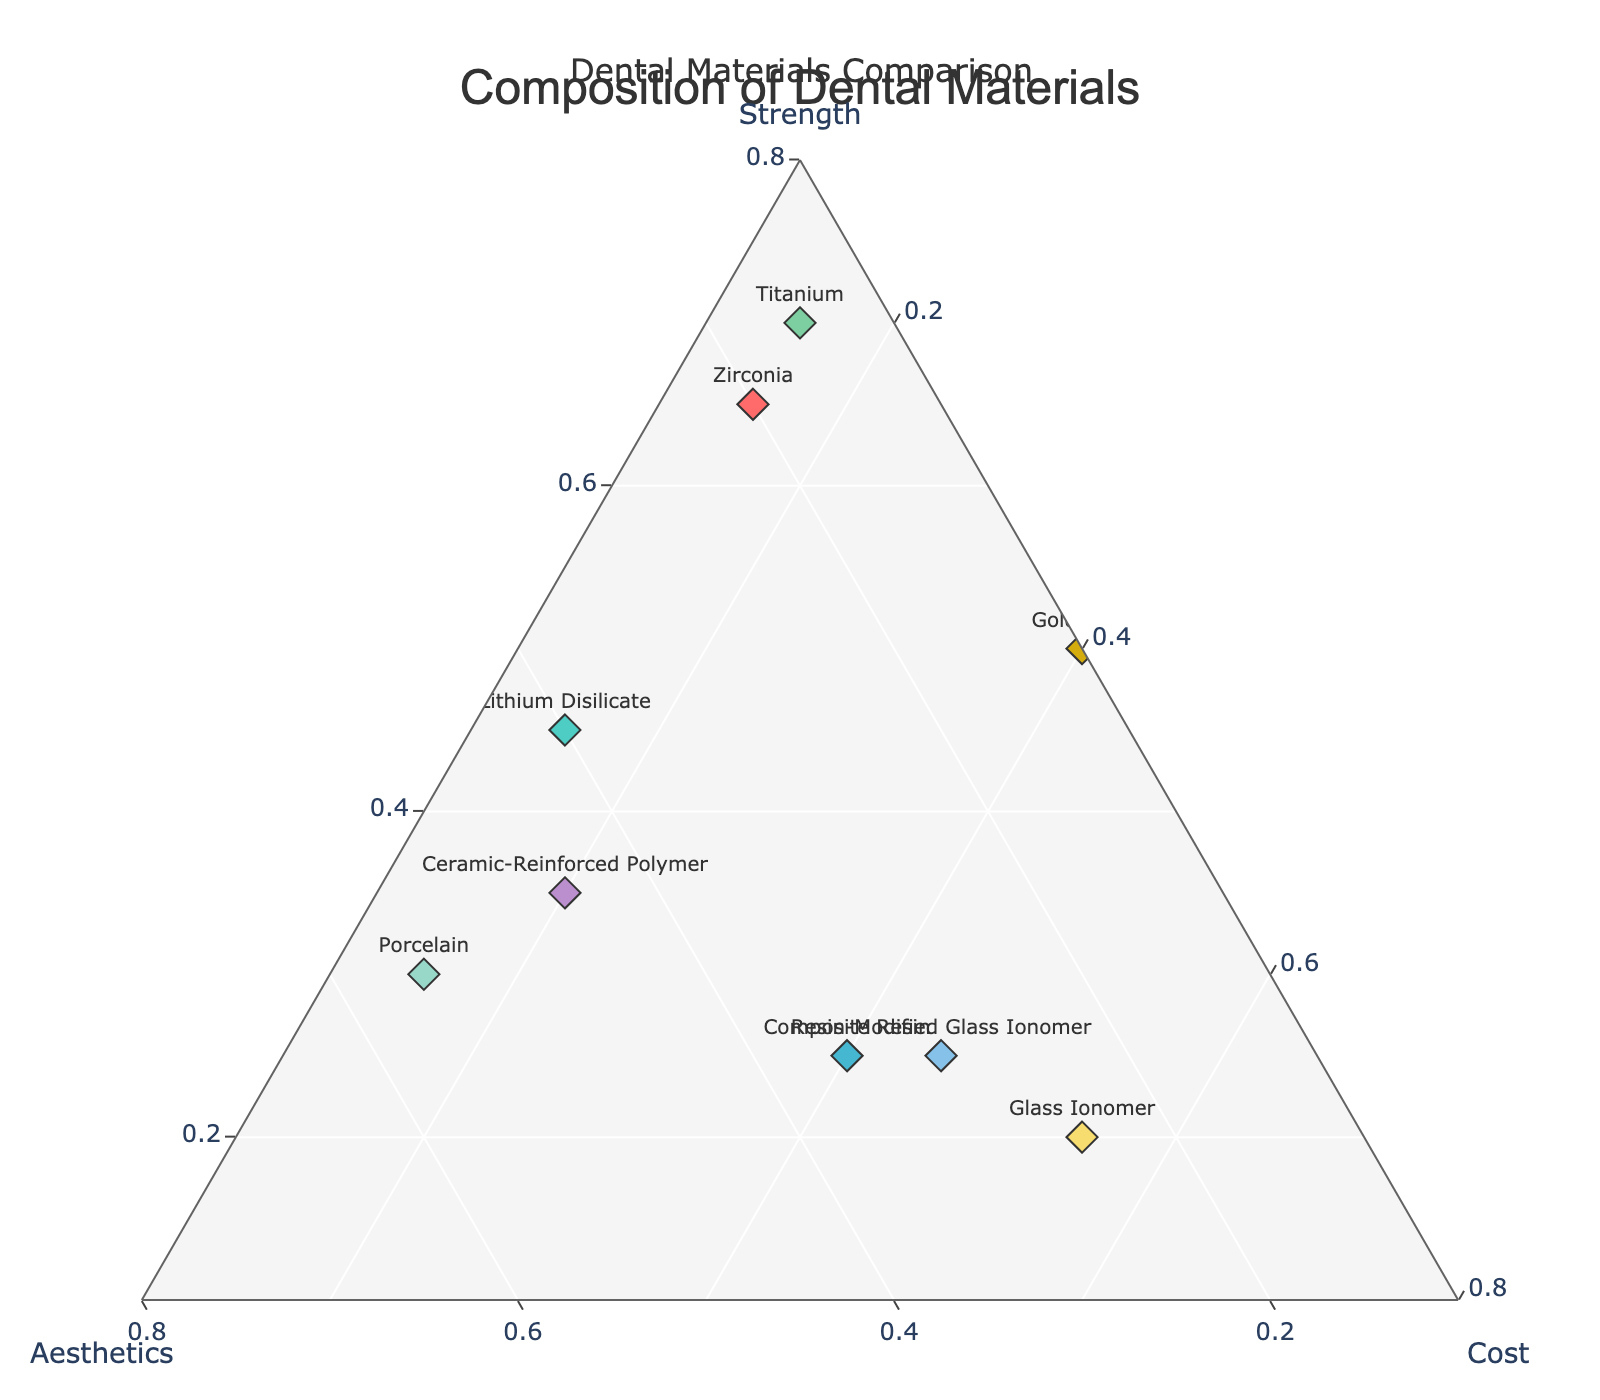What is the title of the figure? The title is usually located at the top of the figure. In this case, it is "Composition of Dental Materials".
Answer: Composition of Dental Materials How many data points (dental materials) are shown in the plot? By counting the labels in the plot, we can see that there are 10 different materials: Zirconia, Lithium Disilicate, Composite Resin, Amalgam, Porcelain, Glass Ionomer, Gold Alloy, Resin-Modified Glass Ionomer, Ceramic-Reinforced Polymer, and Titanium.
Answer: 10 Which material has the highest strength? By looking at the axis labeled "Strength", we observe that Titanium has the highest strength value.
Answer: Titanium Which materials have identical cost percentages? From the data points, we can observe that Zirconia, Lithium Disilicate, Porcelain, and Titanium all have a cost percentage of 0.15.
Answer: Zirconia, Lithium Disilicate, Porcelain, Titanium What is the median value of strength for all materials? To calculate the median value of strength, we first list the strength values in ascending order: 0.20, 0.20, 0.25, 0.25, 0.30, 0.35, 0.45, 0.50, 0.55, 0.65, 0.70. The median is the middle value, which is 0.35.
Answer: 0.35 Which materials are closest to the middle of the ternary plot? By visually inspecting the plot, we find that Composite Resin and Resin-Modified Glass Ionomer seem to be the closest to the center, indicating a more even distribution across strength, aesthetics, and cost.
Answer: Composite Resin, Resin-Modified Glass Ionomer Which material has the lowest aesthetics rating? By looking at the axis labeled "Aesthetics", we observe that Amalgam has the lowest aesthetics value.
Answer: Amalgam Which materials have a strength component greater than 0.50? We identify the materials with strength values greater than 0.50: Zirconia, Amalgam, Gold Alloy, and Titanium.
Answer: Zirconia, Amalgam, Gold Alloy, Titanium What is the sum of aesthetics values for all the materials? By summing up the aesthetics values: 0.20 + 0.40 + 0.35 + 0.05 + 0.55 + 0.25 + 0.10 + 0.30 + 0.45 + 0.15, we get 2.80.
Answer: 2.80 Which material has a balanced composition of strength, aesthetics, and cost? By visually inspecting the plot for materials that are centrally located with relatively equal distribution, Ceramic-Reinforced Polymer stands out as having a balanced composition of strength, aesthetics, and cost.
Answer: Ceramic-Reinforced Polymer 